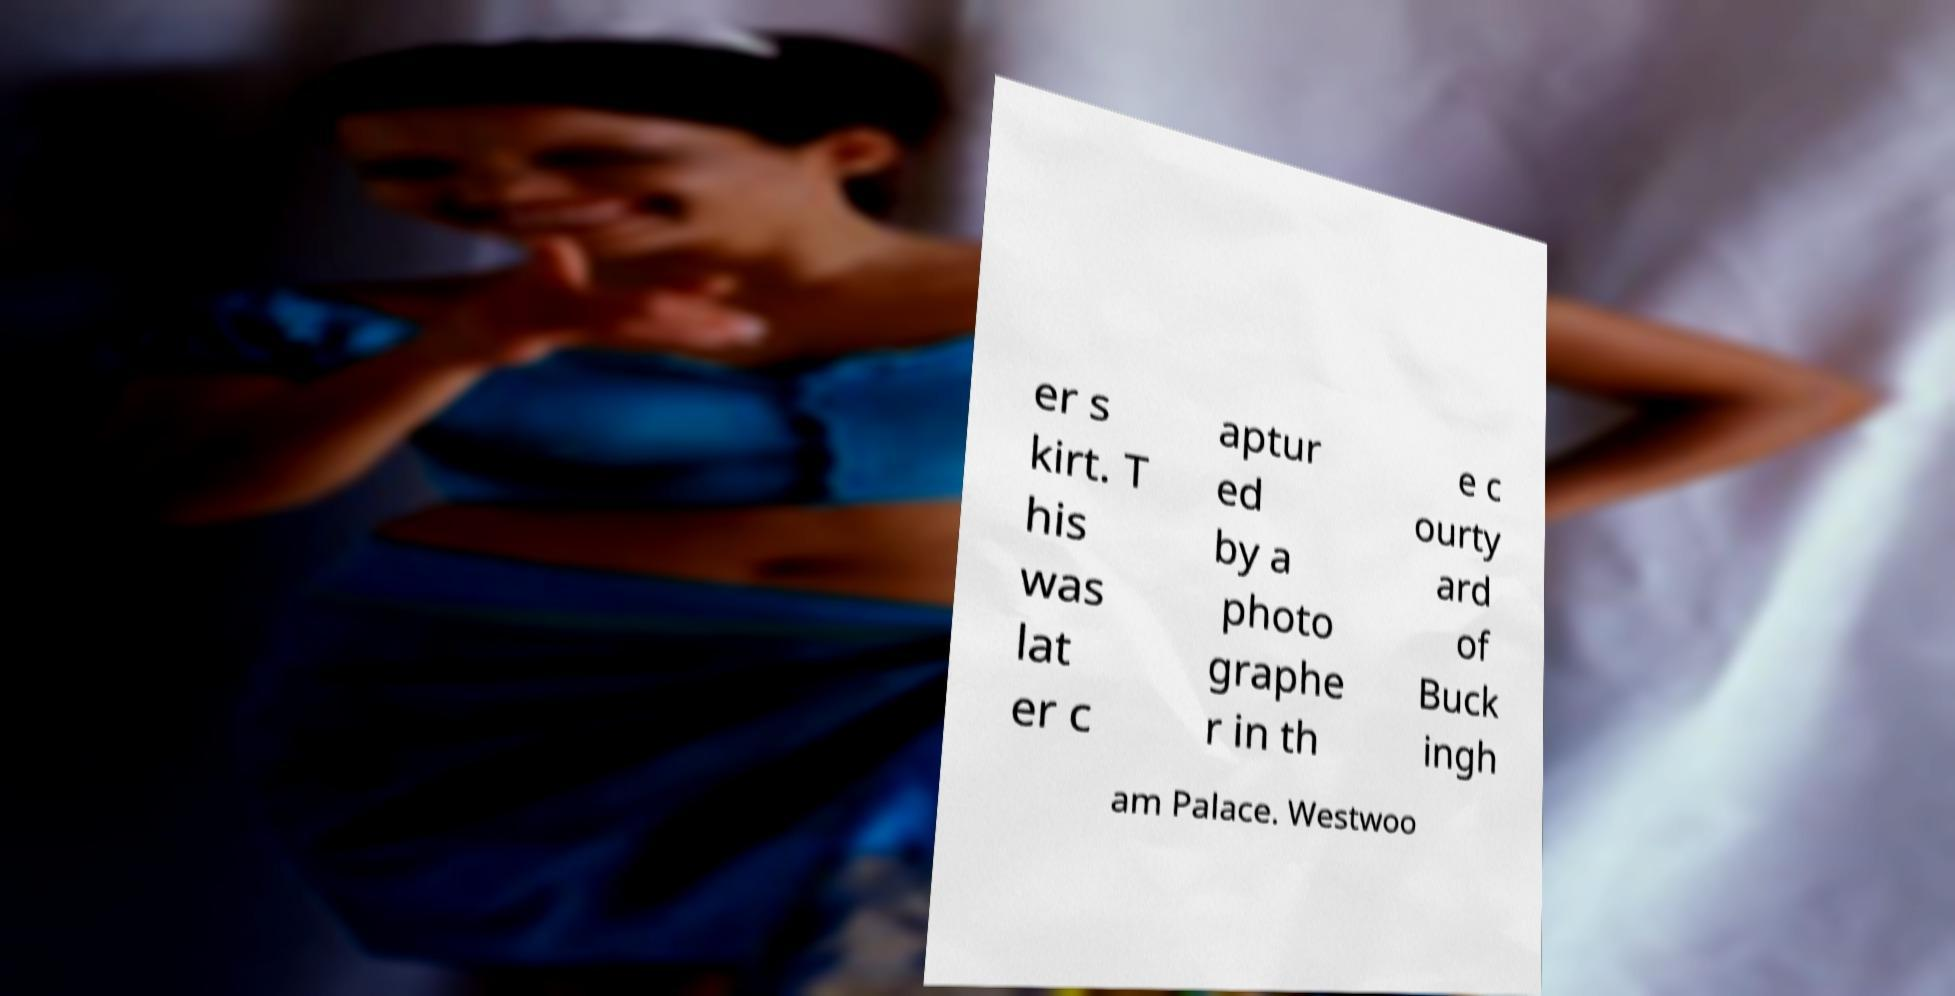Can you read and provide the text displayed in the image?This photo seems to have some interesting text. Can you extract and type it out for me? er s kirt. T his was lat er c aptur ed by a photo graphe r in th e c ourty ard of Buck ingh am Palace. Westwoo 